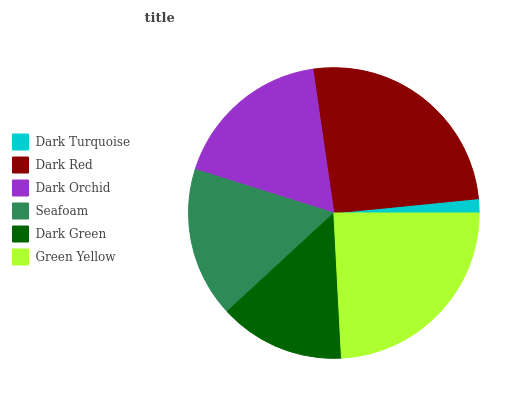Is Dark Turquoise the minimum?
Answer yes or no. Yes. Is Dark Red the maximum?
Answer yes or no. Yes. Is Dark Orchid the minimum?
Answer yes or no. No. Is Dark Orchid the maximum?
Answer yes or no. No. Is Dark Red greater than Dark Orchid?
Answer yes or no. Yes. Is Dark Orchid less than Dark Red?
Answer yes or no. Yes. Is Dark Orchid greater than Dark Red?
Answer yes or no. No. Is Dark Red less than Dark Orchid?
Answer yes or no. No. Is Dark Orchid the high median?
Answer yes or no. Yes. Is Seafoam the low median?
Answer yes or no. Yes. Is Green Yellow the high median?
Answer yes or no. No. Is Dark Turquoise the low median?
Answer yes or no. No. 